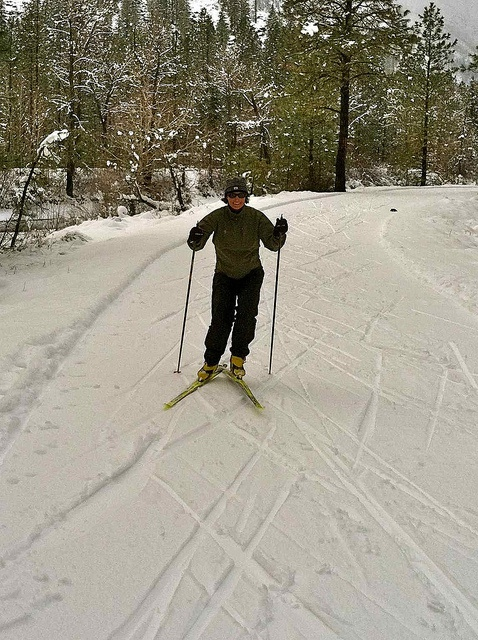Describe the objects in this image and their specific colors. I can see people in gray, black, olive, maroon, and lightgray tones in this image. 